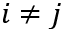Convert formula to latex. <formula><loc_0><loc_0><loc_500><loc_500>i \neq j</formula> 